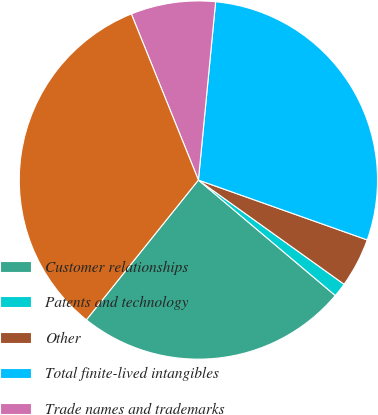Convert chart to OTSL. <chart><loc_0><loc_0><loc_500><loc_500><pie_chart><fcel>Customer relationships<fcel>Patents and technology<fcel>Other<fcel>Total finite-lived intangibles<fcel>Trade names and trademarks<fcel>Total Intangible Assets<nl><fcel>24.6%<fcel>1.27%<fcel>4.46%<fcel>28.89%<fcel>7.64%<fcel>33.14%<nl></chart> 